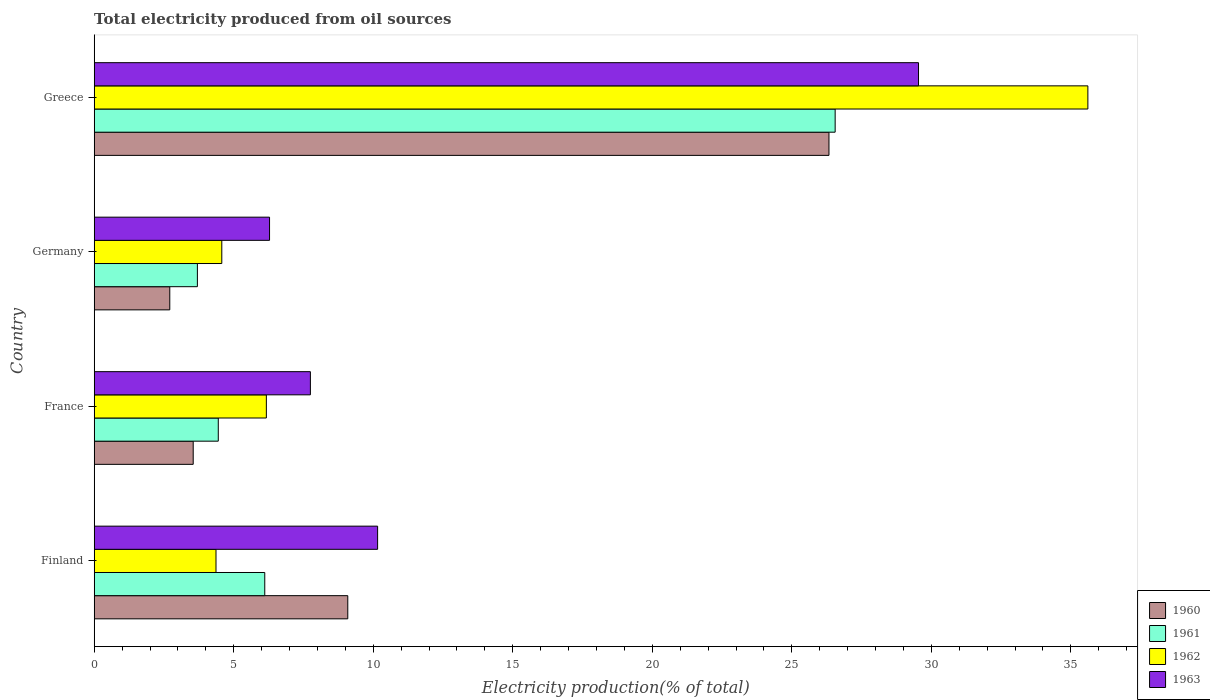How many groups of bars are there?
Provide a succinct answer. 4. Are the number of bars per tick equal to the number of legend labels?
Your response must be concise. Yes. How many bars are there on the 4th tick from the top?
Offer a very short reply. 4. What is the total electricity produced in 1963 in Greece?
Provide a succinct answer. 29.54. Across all countries, what is the maximum total electricity produced in 1962?
Provide a succinct answer. 35.61. Across all countries, what is the minimum total electricity produced in 1962?
Your answer should be compact. 4.36. In which country was the total electricity produced in 1962 minimum?
Give a very brief answer. Finland. What is the total total electricity produced in 1963 in the graph?
Provide a succinct answer. 53.73. What is the difference between the total electricity produced in 1963 in Finland and that in France?
Your answer should be compact. 2.41. What is the difference between the total electricity produced in 1963 in France and the total electricity produced in 1960 in Finland?
Your answer should be very brief. -1.34. What is the average total electricity produced in 1961 per country?
Ensure brevity in your answer.  10.2. What is the difference between the total electricity produced in 1962 and total electricity produced in 1961 in Finland?
Offer a very short reply. -1.75. In how many countries, is the total electricity produced in 1961 greater than 33 %?
Provide a short and direct response. 0. What is the ratio of the total electricity produced in 1963 in France to that in Germany?
Offer a very short reply. 1.23. Is the total electricity produced in 1962 in Finland less than that in Greece?
Keep it short and to the point. Yes. What is the difference between the highest and the second highest total electricity produced in 1962?
Ensure brevity in your answer.  29.44. What is the difference between the highest and the lowest total electricity produced in 1963?
Offer a very short reply. 23.26. In how many countries, is the total electricity produced in 1961 greater than the average total electricity produced in 1961 taken over all countries?
Ensure brevity in your answer.  1. Is the sum of the total electricity produced in 1962 in Finland and Germany greater than the maximum total electricity produced in 1960 across all countries?
Offer a terse response. No. Is it the case that in every country, the sum of the total electricity produced in 1962 and total electricity produced in 1963 is greater than the sum of total electricity produced in 1960 and total electricity produced in 1961?
Keep it short and to the point. No. What does the 3rd bar from the bottom in Germany represents?
Your response must be concise. 1962. Is it the case that in every country, the sum of the total electricity produced in 1960 and total electricity produced in 1961 is greater than the total electricity produced in 1962?
Your response must be concise. Yes. How many bars are there?
Keep it short and to the point. 16. What is the difference between two consecutive major ticks on the X-axis?
Keep it short and to the point. 5. Does the graph contain grids?
Your response must be concise. No. Where does the legend appear in the graph?
Your answer should be very brief. Bottom right. How many legend labels are there?
Give a very brief answer. 4. What is the title of the graph?
Your answer should be very brief. Total electricity produced from oil sources. Does "1985" appear as one of the legend labels in the graph?
Your response must be concise. No. What is the Electricity production(% of total) in 1960 in Finland?
Provide a short and direct response. 9.09. What is the Electricity production(% of total) in 1961 in Finland?
Keep it short and to the point. 6.11. What is the Electricity production(% of total) of 1962 in Finland?
Offer a terse response. 4.36. What is the Electricity production(% of total) of 1963 in Finland?
Give a very brief answer. 10.16. What is the Electricity production(% of total) of 1960 in France?
Your answer should be compact. 3.55. What is the Electricity production(% of total) in 1961 in France?
Your answer should be very brief. 4.45. What is the Electricity production(% of total) of 1962 in France?
Your response must be concise. 6.17. What is the Electricity production(% of total) in 1963 in France?
Ensure brevity in your answer.  7.75. What is the Electricity production(% of total) in 1960 in Germany?
Provide a short and direct response. 2.71. What is the Electricity production(% of total) of 1961 in Germany?
Provide a short and direct response. 3.7. What is the Electricity production(% of total) of 1962 in Germany?
Offer a very short reply. 4.57. What is the Electricity production(% of total) in 1963 in Germany?
Your answer should be compact. 6.28. What is the Electricity production(% of total) of 1960 in Greece?
Your response must be concise. 26.33. What is the Electricity production(% of total) in 1961 in Greece?
Make the answer very short. 26.55. What is the Electricity production(% of total) of 1962 in Greece?
Your answer should be very brief. 35.61. What is the Electricity production(% of total) of 1963 in Greece?
Offer a very short reply. 29.54. Across all countries, what is the maximum Electricity production(% of total) in 1960?
Provide a short and direct response. 26.33. Across all countries, what is the maximum Electricity production(% of total) in 1961?
Offer a very short reply. 26.55. Across all countries, what is the maximum Electricity production(% of total) in 1962?
Your answer should be very brief. 35.61. Across all countries, what is the maximum Electricity production(% of total) of 1963?
Give a very brief answer. 29.54. Across all countries, what is the minimum Electricity production(% of total) in 1960?
Offer a very short reply. 2.71. Across all countries, what is the minimum Electricity production(% of total) in 1961?
Your response must be concise. 3.7. Across all countries, what is the minimum Electricity production(% of total) of 1962?
Provide a succinct answer. 4.36. Across all countries, what is the minimum Electricity production(% of total) in 1963?
Keep it short and to the point. 6.28. What is the total Electricity production(% of total) in 1960 in the graph?
Provide a succinct answer. 41.68. What is the total Electricity production(% of total) of 1961 in the graph?
Make the answer very short. 40.81. What is the total Electricity production(% of total) in 1962 in the graph?
Your answer should be very brief. 50.72. What is the total Electricity production(% of total) of 1963 in the graph?
Make the answer very short. 53.73. What is the difference between the Electricity production(% of total) of 1960 in Finland and that in France?
Give a very brief answer. 5.54. What is the difference between the Electricity production(% of total) in 1961 in Finland and that in France?
Your answer should be very brief. 1.67. What is the difference between the Electricity production(% of total) of 1962 in Finland and that in France?
Keep it short and to the point. -1.8. What is the difference between the Electricity production(% of total) of 1963 in Finland and that in France?
Your response must be concise. 2.41. What is the difference between the Electricity production(% of total) of 1960 in Finland and that in Germany?
Ensure brevity in your answer.  6.38. What is the difference between the Electricity production(% of total) of 1961 in Finland and that in Germany?
Make the answer very short. 2.41. What is the difference between the Electricity production(% of total) in 1962 in Finland and that in Germany?
Offer a terse response. -0.21. What is the difference between the Electricity production(% of total) of 1963 in Finland and that in Germany?
Your response must be concise. 3.87. What is the difference between the Electricity production(% of total) in 1960 in Finland and that in Greece?
Ensure brevity in your answer.  -17.24. What is the difference between the Electricity production(% of total) of 1961 in Finland and that in Greece?
Offer a terse response. -20.44. What is the difference between the Electricity production(% of total) of 1962 in Finland and that in Greece?
Your answer should be compact. -31.25. What is the difference between the Electricity production(% of total) in 1963 in Finland and that in Greece?
Ensure brevity in your answer.  -19.38. What is the difference between the Electricity production(% of total) in 1960 in France and that in Germany?
Ensure brevity in your answer.  0.84. What is the difference between the Electricity production(% of total) in 1961 in France and that in Germany?
Keep it short and to the point. 0.75. What is the difference between the Electricity production(% of total) of 1962 in France and that in Germany?
Keep it short and to the point. 1.6. What is the difference between the Electricity production(% of total) of 1963 in France and that in Germany?
Give a very brief answer. 1.46. What is the difference between the Electricity production(% of total) of 1960 in France and that in Greece?
Provide a succinct answer. -22.78. What is the difference between the Electricity production(% of total) of 1961 in France and that in Greece?
Provide a short and direct response. -22.11. What is the difference between the Electricity production(% of total) in 1962 in France and that in Greece?
Your answer should be very brief. -29.44. What is the difference between the Electricity production(% of total) in 1963 in France and that in Greece?
Your answer should be compact. -21.79. What is the difference between the Electricity production(% of total) in 1960 in Germany and that in Greece?
Provide a succinct answer. -23.62. What is the difference between the Electricity production(% of total) in 1961 in Germany and that in Greece?
Your answer should be compact. -22.86. What is the difference between the Electricity production(% of total) in 1962 in Germany and that in Greece?
Offer a terse response. -31.04. What is the difference between the Electricity production(% of total) of 1963 in Germany and that in Greece?
Make the answer very short. -23.26. What is the difference between the Electricity production(% of total) in 1960 in Finland and the Electricity production(% of total) in 1961 in France?
Provide a short and direct response. 4.64. What is the difference between the Electricity production(% of total) in 1960 in Finland and the Electricity production(% of total) in 1962 in France?
Keep it short and to the point. 2.92. What is the difference between the Electricity production(% of total) of 1960 in Finland and the Electricity production(% of total) of 1963 in France?
Your answer should be compact. 1.34. What is the difference between the Electricity production(% of total) of 1961 in Finland and the Electricity production(% of total) of 1962 in France?
Offer a very short reply. -0.06. What is the difference between the Electricity production(% of total) in 1961 in Finland and the Electricity production(% of total) in 1963 in France?
Offer a terse response. -1.64. What is the difference between the Electricity production(% of total) in 1962 in Finland and the Electricity production(% of total) in 1963 in France?
Provide a short and direct response. -3.38. What is the difference between the Electricity production(% of total) in 1960 in Finland and the Electricity production(% of total) in 1961 in Germany?
Offer a terse response. 5.39. What is the difference between the Electricity production(% of total) of 1960 in Finland and the Electricity production(% of total) of 1962 in Germany?
Provide a short and direct response. 4.51. What is the difference between the Electricity production(% of total) of 1960 in Finland and the Electricity production(% of total) of 1963 in Germany?
Give a very brief answer. 2.8. What is the difference between the Electricity production(% of total) in 1961 in Finland and the Electricity production(% of total) in 1962 in Germany?
Provide a short and direct response. 1.54. What is the difference between the Electricity production(% of total) in 1961 in Finland and the Electricity production(% of total) in 1963 in Germany?
Offer a very short reply. -0.17. What is the difference between the Electricity production(% of total) in 1962 in Finland and the Electricity production(% of total) in 1963 in Germany?
Provide a short and direct response. -1.92. What is the difference between the Electricity production(% of total) in 1960 in Finland and the Electricity production(% of total) in 1961 in Greece?
Your answer should be compact. -17.47. What is the difference between the Electricity production(% of total) of 1960 in Finland and the Electricity production(% of total) of 1962 in Greece?
Give a very brief answer. -26.52. What is the difference between the Electricity production(% of total) of 1960 in Finland and the Electricity production(% of total) of 1963 in Greece?
Make the answer very short. -20.45. What is the difference between the Electricity production(% of total) of 1961 in Finland and the Electricity production(% of total) of 1962 in Greece?
Your response must be concise. -29.5. What is the difference between the Electricity production(% of total) in 1961 in Finland and the Electricity production(% of total) in 1963 in Greece?
Give a very brief answer. -23.43. What is the difference between the Electricity production(% of total) in 1962 in Finland and the Electricity production(% of total) in 1963 in Greece?
Provide a succinct answer. -25.18. What is the difference between the Electricity production(% of total) in 1960 in France and the Electricity production(% of total) in 1961 in Germany?
Provide a succinct answer. -0.15. What is the difference between the Electricity production(% of total) in 1960 in France and the Electricity production(% of total) in 1962 in Germany?
Ensure brevity in your answer.  -1.02. What is the difference between the Electricity production(% of total) of 1960 in France and the Electricity production(% of total) of 1963 in Germany?
Your answer should be very brief. -2.74. What is the difference between the Electricity production(% of total) of 1961 in France and the Electricity production(% of total) of 1962 in Germany?
Provide a succinct answer. -0.13. What is the difference between the Electricity production(% of total) in 1961 in France and the Electricity production(% of total) in 1963 in Germany?
Provide a succinct answer. -1.84. What is the difference between the Electricity production(% of total) of 1962 in France and the Electricity production(% of total) of 1963 in Germany?
Your response must be concise. -0.11. What is the difference between the Electricity production(% of total) of 1960 in France and the Electricity production(% of total) of 1961 in Greece?
Provide a succinct answer. -23.01. What is the difference between the Electricity production(% of total) of 1960 in France and the Electricity production(% of total) of 1962 in Greece?
Your answer should be compact. -32.06. What is the difference between the Electricity production(% of total) in 1960 in France and the Electricity production(% of total) in 1963 in Greece?
Ensure brevity in your answer.  -25.99. What is the difference between the Electricity production(% of total) of 1961 in France and the Electricity production(% of total) of 1962 in Greece?
Ensure brevity in your answer.  -31.16. What is the difference between the Electricity production(% of total) in 1961 in France and the Electricity production(% of total) in 1963 in Greece?
Provide a short and direct response. -25.09. What is the difference between the Electricity production(% of total) of 1962 in France and the Electricity production(% of total) of 1963 in Greece?
Provide a succinct answer. -23.37. What is the difference between the Electricity production(% of total) of 1960 in Germany and the Electricity production(% of total) of 1961 in Greece?
Provide a succinct answer. -23.85. What is the difference between the Electricity production(% of total) in 1960 in Germany and the Electricity production(% of total) in 1962 in Greece?
Your response must be concise. -32.9. What is the difference between the Electricity production(% of total) of 1960 in Germany and the Electricity production(% of total) of 1963 in Greece?
Make the answer very short. -26.83. What is the difference between the Electricity production(% of total) of 1961 in Germany and the Electricity production(% of total) of 1962 in Greece?
Give a very brief answer. -31.91. What is the difference between the Electricity production(% of total) in 1961 in Germany and the Electricity production(% of total) in 1963 in Greece?
Keep it short and to the point. -25.84. What is the difference between the Electricity production(% of total) in 1962 in Germany and the Electricity production(% of total) in 1963 in Greece?
Your answer should be compact. -24.97. What is the average Electricity production(% of total) in 1960 per country?
Offer a very short reply. 10.42. What is the average Electricity production(% of total) of 1961 per country?
Your answer should be very brief. 10.2. What is the average Electricity production(% of total) of 1962 per country?
Provide a succinct answer. 12.68. What is the average Electricity production(% of total) of 1963 per country?
Provide a succinct answer. 13.43. What is the difference between the Electricity production(% of total) of 1960 and Electricity production(% of total) of 1961 in Finland?
Provide a short and direct response. 2.98. What is the difference between the Electricity production(% of total) of 1960 and Electricity production(% of total) of 1962 in Finland?
Your answer should be very brief. 4.72. What is the difference between the Electricity production(% of total) in 1960 and Electricity production(% of total) in 1963 in Finland?
Make the answer very short. -1.07. What is the difference between the Electricity production(% of total) in 1961 and Electricity production(% of total) in 1962 in Finland?
Make the answer very short. 1.75. What is the difference between the Electricity production(% of total) of 1961 and Electricity production(% of total) of 1963 in Finland?
Offer a terse response. -4.04. What is the difference between the Electricity production(% of total) of 1962 and Electricity production(% of total) of 1963 in Finland?
Your response must be concise. -5.79. What is the difference between the Electricity production(% of total) of 1960 and Electricity production(% of total) of 1961 in France?
Provide a short and direct response. -0.9. What is the difference between the Electricity production(% of total) of 1960 and Electricity production(% of total) of 1962 in France?
Provide a short and direct response. -2.62. What is the difference between the Electricity production(% of total) in 1960 and Electricity production(% of total) in 1963 in France?
Provide a succinct answer. -4.2. What is the difference between the Electricity production(% of total) of 1961 and Electricity production(% of total) of 1962 in France?
Make the answer very short. -1.72. What is the difference between the Electricity production(% of total) in 1961 and Electricity production(% of total) in 1963 in France?
Provide a succinct answer. -3.3. What is the difference between the Electricity production(% of total) in 1962 and Electricity production(% of total) in 1963 in France?
Keep it short and to the point. -1.58. What is the difference between the Electricity production(% of total) of 1960 and Electricity production(% of total) of 1961 in Germany?
Provide a succinct answer. -0.99. What is the difference between the Electricity production(% of total) of 1960 and Electricity production(% of total) of 1962 in Germany?
Your answer should be compact. -1.86. What is the difference between the Electricity production(% of total) of 1960 and Electricity production(% of total) of 1963 in Germany?
Offer a terse response. -3.58. What is the difference between the Electricity production(% of total) in 1961 and Electricity production(% of total) in 1962 in Germany?
Offer a terse response. -0.87. What is the difference between the Electricity production(% of total) in 1961 and Electricity production(% of total) in 1963 in Germany?
Your answer should be very brief. -2.59. What is the difference between the Electricity production(% of total) of 1962 and Electricity production(% of total) of 1963 in Germany?
Offer a terse response. -1.71. What is the difference between the Electricity production(% of total) in 1960 and Electricity production(% of total) in 1961 in Greece?
Provide a short and direct response. -0.22. What is the difference between the Electricity production(% of total) in 1960 and Electricity production(% of total) in 1962 in Greece?
Make the answer very short. -9.28. What is the difference between the Electricity production(% of total) in 1960 and Electricity production(% of total) in 1963 in Greece?
Your answer should be very brief. -3.21. What is the difference between the Electricity production(% of total) of 1961 and Electricity production(% of total) of 1962 in Greece?
Provide a short and direct response. -9.06. What is the difference between the Electricity production(% of total) of 1961 and Electricity production(% of total) of 1963 in Greece?
Offer a very short reply. -2.99. What is the difference between the Electricity production(% of total) in 1962 and Electricity production(% of total) in 1963 in Greece?
Give a very brief answer. 6.07. What is the ratio of the Electricity production(% of total) in 1960 in Finland to that in France?
Your answer should be compact. 2.56. What is the ratio of the Electricity production(% of total) in 1961 in Finland to that in France?
Offer a very short reply. 1.37. What is the ratio of the Electricity production(% of total) in 1962 in Finland to that in France?
Your answer should be compact. 0.71. What is the ratio of the Electricity production(% of total) of 1963 in Finland to that in France?
Make the answer very short. 1.31. What is the ratio of the Electricity production(% of total) of 1960 in Finland to that in Germany?
Offer a terse response. 3.36. What is the ratio of the Electricity production(% of total) in 1961 in Finland to that in Germany?
Your response must be concise. 1.65. What is the ratio of the Electricity production(% of total) in 1962 in Finland to that in Germany?
Make the answer very short. 0.95. What is the ratio of the Electricity production(% of total) of 1963 in Finland to that in Germany?
Keep it short and to the point. 1.62. What is the ratio of the Electricity production(% of total) of 1960 in Finland to that in Greece?
Make the answer very short. 0.35. What is the ratio of the Electricity production(% of total) in 1961 in Finland to that in Greece?
Make the answer very short. 0.23. What is the ratio of the Electricity production(% of total) in 1962 in Finland to that in Greece?
Your answer should be compact. 0.12. What is the ratio of the Electricity production(% of total) of 1963 in Finland to that in Greece?
Give a very brief answer. 0.34. What is the ratio of the Electricity production(% of total) in 1960 in France to that in Germany?
Provide a short and direct response. 1.31. What is the ratio of the Electricity production(% of total) in 1961 in France to that in Germany?
Offer a terse response. 1.2. What is the ratio of the Electricity production(% of total) in 1962 in France to that in Germany?
Make the answer very short. 1.35. What is the ratio of the Electricity production(% of total) of 1963 in France to that in Germany?
Provide a succinct answer. 1.23. What is the ratio of the Electricity production(% of total) of 1960 in France to that in Greece?
Provide a short and direct response. 0.13. What is the ratio of the Electricity production(% of total) in 1961 in France to that in Greece?
Provide a short and direct response. 0.17. What is the ratio of the Electricity production(% of total) in 1962 in France to that in Greece?
Your response must be concise. 0.17. What is the ratio of the Electricity production(% of total) of 1963 in France to that in Greece?
Keep it short and to the point. 0.26. What is the ratio of the Electricity production(% of total) of 1960 in Germany to that in Greece?
Offer a terse response. 0.1. What is the ratio of the Electricity production(% of total) in 1961 in Germany to that in Greece?
Offer a very short reply. 0.14. What is the ratio of the Electricity production(% of total) of 1962 in Germany to that in Greece?
Ensure brevity in your answer.  0.13. What is the ratio of the Electricity production(% of total) of 1963 in Germany to that in Greece?
Your response must be concise. 0.21. What is the difference between the highest and the second highest Electricity production(% of total) in 1960?
Provide a short and direct response. 17.24. What is the difference between the highest and the second highest Electricity production(% of total) in 1961?
Your response must be concise. 20.44. What is the difference between the highest and the second highest Electricity production(% of total) of 1962?
Make the answer very short. 29.44. What is the difference between the highest and the second highest Electricity production(% of total) in 1963?
Your response must be concise. 19.38. What is the difference between the highest and the lowest Electricity production(% of total) in 1960?
Provide a succinct answer. 23.62. What is the difference between the highest and the lowest Electricity production(% of total) in 1961?
Keep it short and to the point. 22.86. What is the difference between the highest and the lowest Electricity production(% of total) of 1962?
Give a very brief answer. 31.25. What is the difference between the highest and the lowest Electricity production(% of total) of 1963?
Offer a terse response. 23.26. 